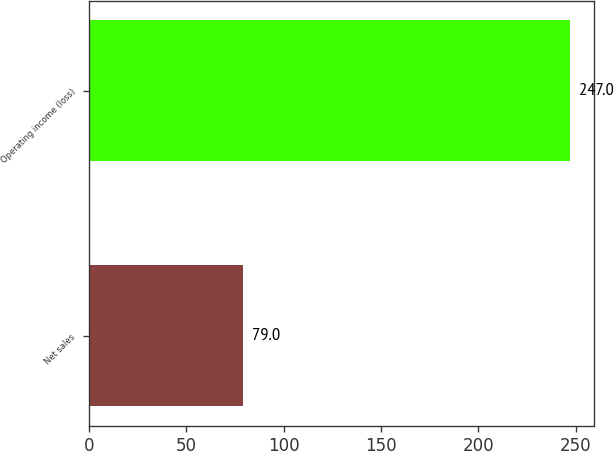<chart> <loc_0><loc_0><loc_500><loc_500><bar_chart><fcel>Net sales<fcel>Operating income (loss)<nl><fcel>79<fcel>247<nl></chart> 